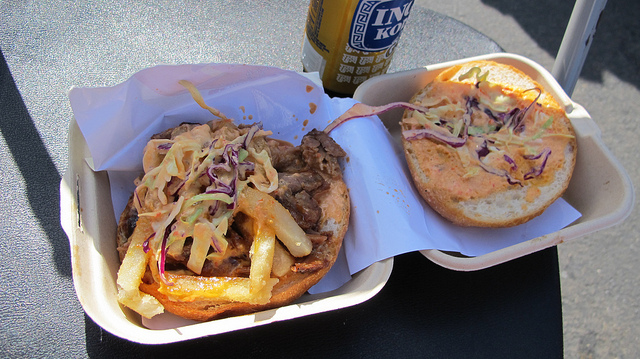Extract all visible text content from this image. INU KO 